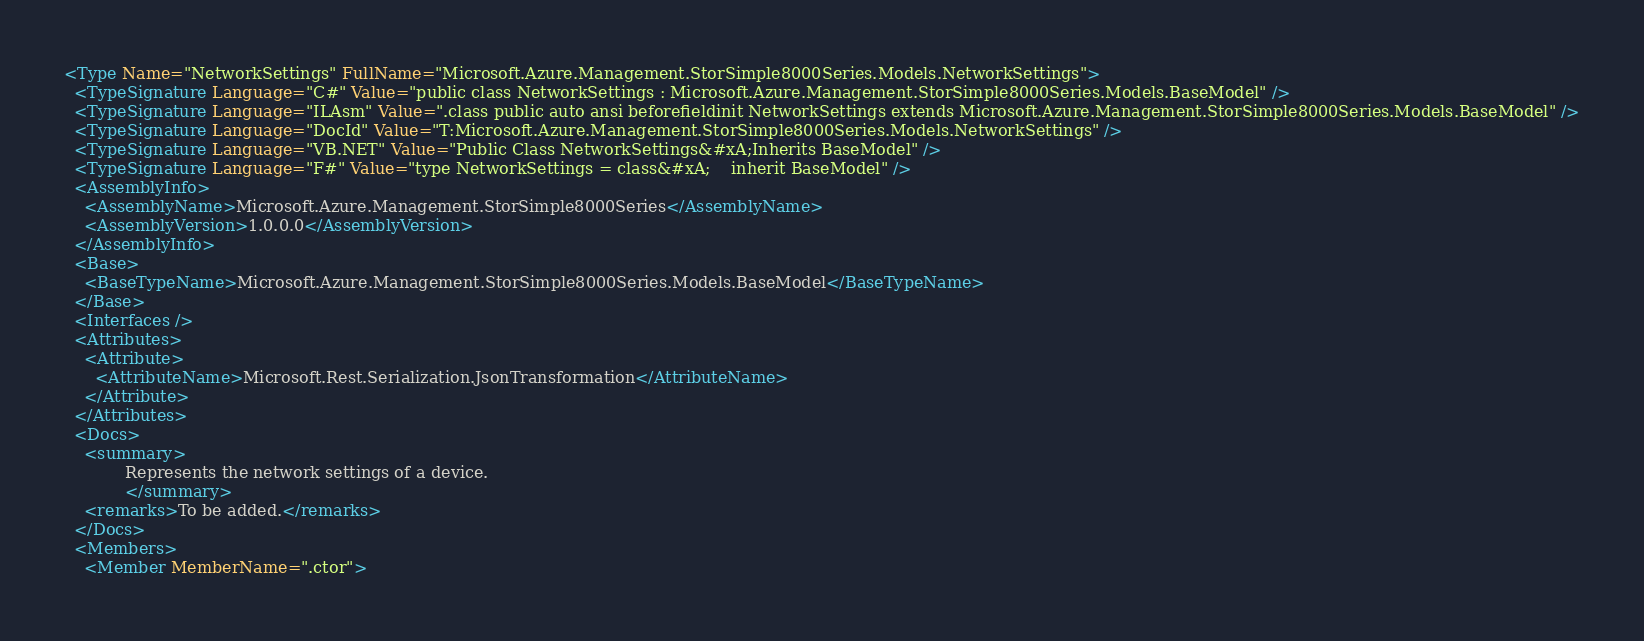<code> <loc_0><loc_0><loc_500><loc_500><_XML_><Type Name="NetworkSettings" FullName="Microsoft.Azure.Management.StorSimple8000Series.Models.NetworkSettings">
  <TypeSignature Language="C#" Value="public class NetworkSettings : Microsoft.Azure.Management.StorSimple8000Series.Models.BaseModel" />
  <TypeSignature Language="ILAsm" Value=".class public auto ansi beforefieldinit NetworkSettings extends Microsoft.Azure.Management.StorSimple8000Series.Models.BaseModel" />
  <TypeSignature Language="DocId" Value="T:Microsoft.Azure.Management.StorSimple8000Series.Models.NetworkSettings" />
  <TypeSignature Language="VB.NET" Value="Public Class NetworkSettings&#xA;Inherits BaseModel" />
  <TypeSignature Language="F#" Value="type NetworkSettings = class&#xA;    inherit BaseModel" />
  <AssemblyInfo>
    <AssemblyName>Microsoft.Azure.Management.StorSimple8000Series</AssemblyName>
    <AssemblyVersion>1.0.0.0</AssemblyVersion>
  </AssemblyInfo>
  <Base>
    <BaseTypeName>Microsoft.Azure.Management.StorSimple8000Series.Models.BaseModel</BaseTypeName>
  </Base>
  <Interfaces />
  <Attributes>
    <Attribute>
      <AttributeName>Microsoft.Rest.Serialization.JsonTransformation</AttributeName>
    </Attribute>
  </Attributes>
  <Docs>
    <summary>
            Represents the network settings of a device.
            </summary>
    <remarks>To be added.</remarks>
  </Docs>
  <Members>
    <Member MemberName=".ctor"></code> 